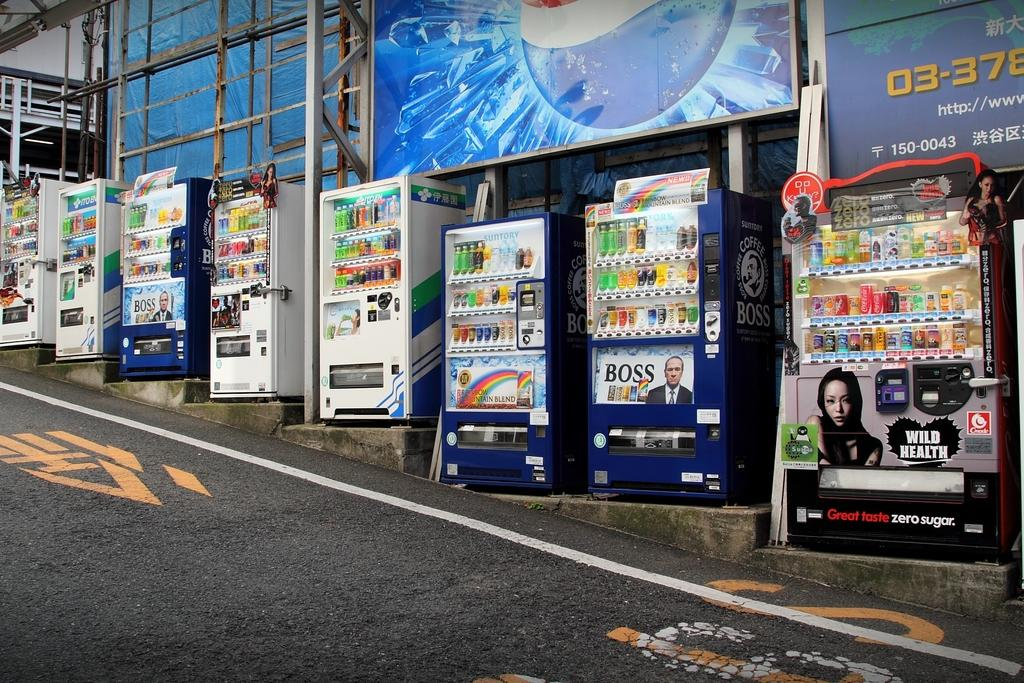Provide a one-sentence caption for the provided image. A Wild Heath vending machine sits on the side of a street. 